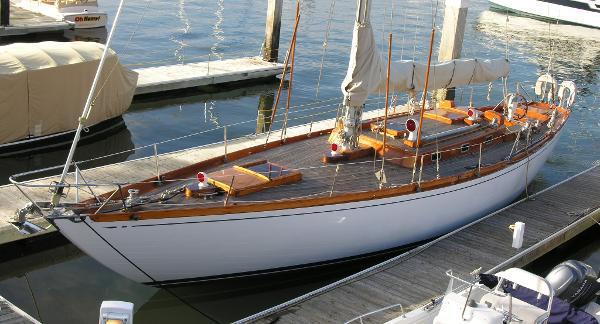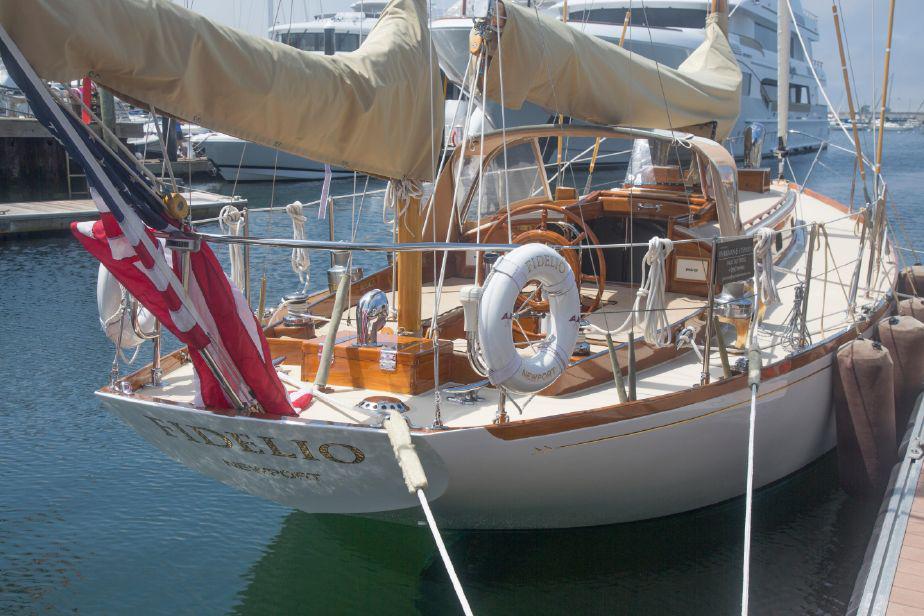The first image is the image on the left, the second image is the image on the right. Evaluate the accuracy of this statement regarding the images: "Atleast one of the pictures doesn't have a white boat.". Is it true? Answer yes or no. No. The first image is the image on the left, the second image is the image on the right. For the images shown, is this caption "Some of the boats have multiple flags attached to them and none are American Flags." true? Answer yes or no. No. 